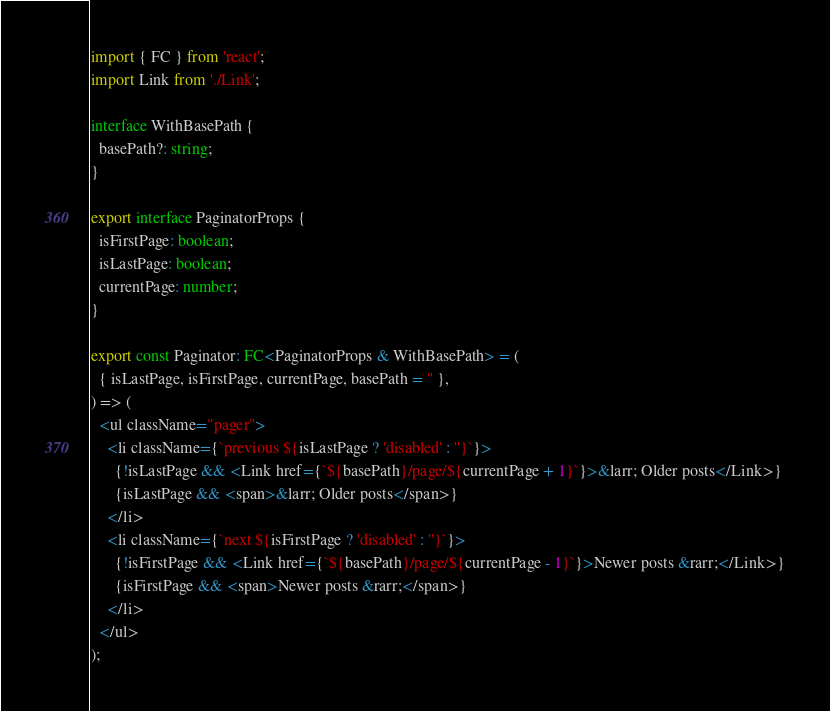Convert code to text. <code><loc_0><loc_0><loc_500><loc_500><_TypeScript_>import { FC } from 'react';
import Link from './Link';

interface WithBasePath {
  basePath?: string;
}

export interface PaginatorProps {
  isFirstPage: boolean;
  isLastPage: boolean;
  currentPage: number;
}

export const Paginator: FC<PaginatorProps & WithBasePath> = (
  { isLastPage, isFirstPage, currentPage, basePath = '' },
) => (
  <ul className="pager">
    <li className={`previous ${isLastPage ? 'disabled' : ''}`}>
      {!isLastPage && <Link href={`${basePath}/page/${currentPage + 1}`}>&larr; Older posts</Link>}
      {isLastPage && <span>&larr; Older posts</span>}
    </li>
    <li className={`next ${isFirstPage ? 'disabled' : ''}`}>
      {!isFirstPage && <Link href={`${basePath}/page/${currentPage - 1}`}>Newer posts &rarr;</Link>}
      {isFirstPage && <span>Newer posts &rarr;</span>}
    </li>
  </ul>
);
</code> 